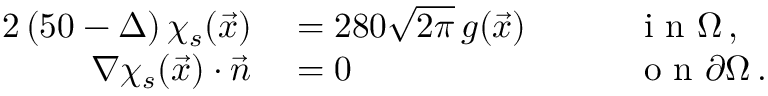<formula> <loc_0><loc_0><loc_500><loc_500>\begin{array} { r l r l } { { 2 } \left ( 5 0 - \Delta \right ) \chi _ { s } ( \vec { x } ) } & = 2 8 0 \sqrt { 2 \pi } \, g ( \vec { x } ) \quad } & i n \Omega \, , } \\ { \nabla \chi _ { s } ( \vec { x } ) \cdot \vec { n } } & = 0 \quad } & o n \partial \Omega \, . } \end{array}</formula> 